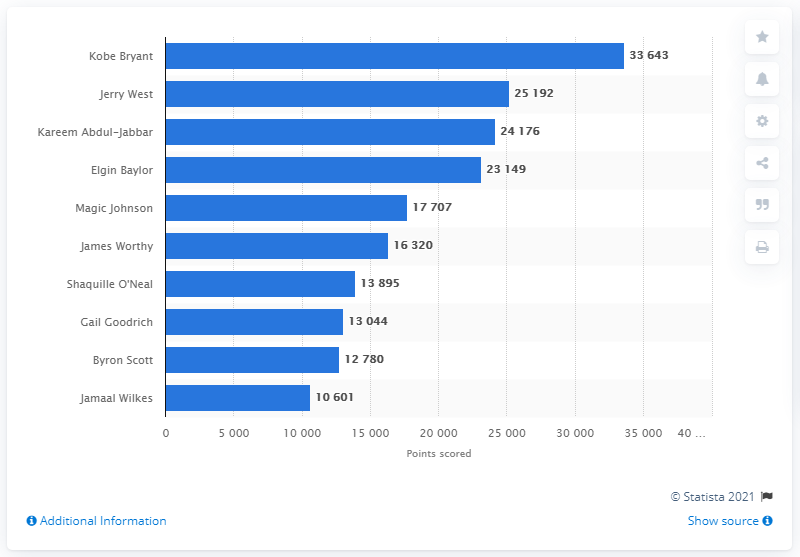Draw attention to some important aspects in this diagram. The career points leader of the Los Angeles Lakers is Kobe Bryant. 